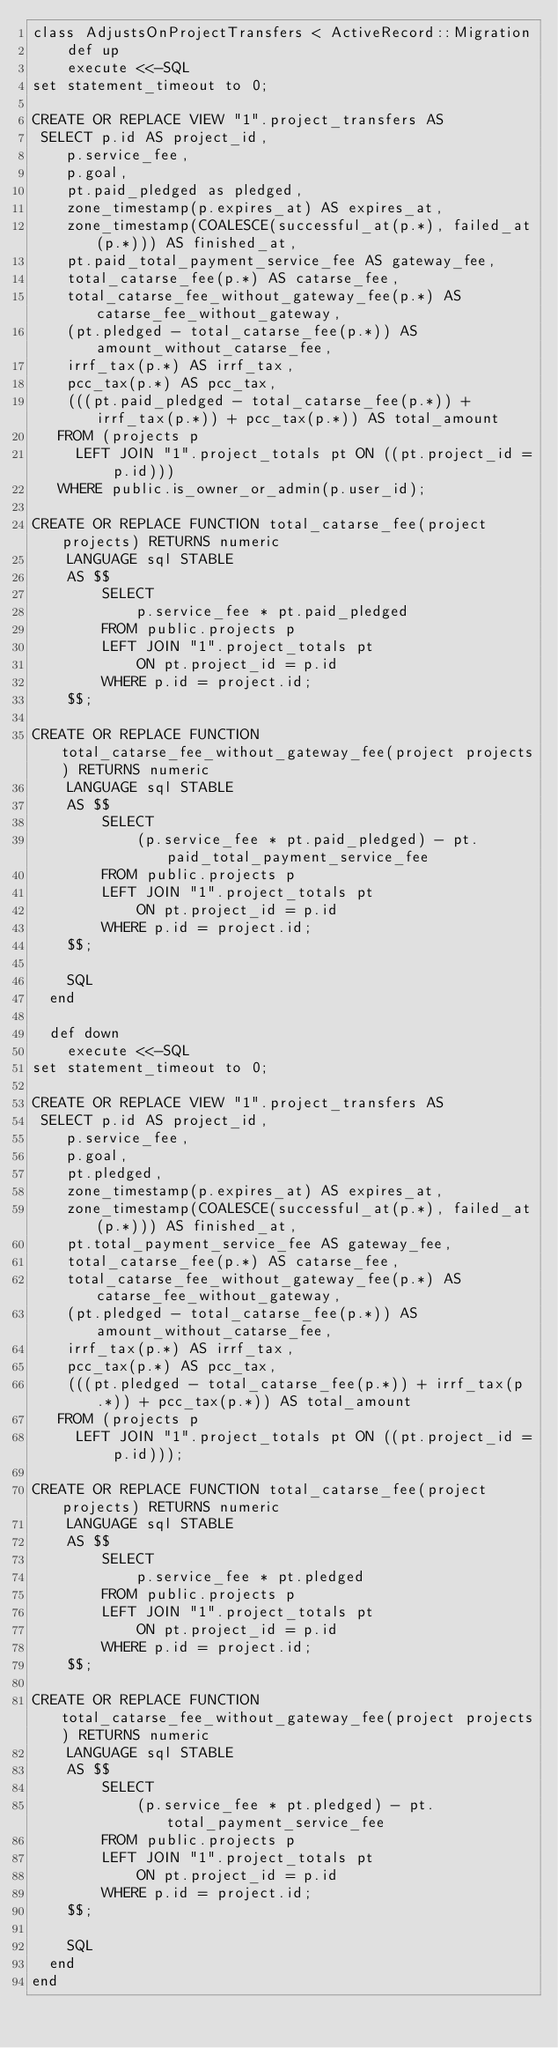<code> <loc_0><loc_0><loc_500><loc_500><_Ruby_>class AdjustsOnProjectTransfers < ActiveRecord::Migration
    def up
    execute <<-SQL
set statement_timeout to 0;

CREATE OR REPLACE VIEW "1".project_transfers AS
 SELECT p.id AS project_id,
    p.service_fee,
    p.goal,
    pt.paid_pledged as pledged,
    zone_timestamp(p.expires_at) AS expires_at,
    zone_timestamp(COALESCE(successful_at(p.*), failed_at(p.*))) AS finished_at,
    pt.paid_total_payment_service_fee AS gateway_fee,
    total_catarse_fee(p.*) AS catarse_fee,
    total_catarse_fee_without_gateway_fee(p.*) AS catarse_fee_without_gateway,
    (pt.pledged - total_catarse_fee(p.*)) AS amount_without_catarse_fee,
    irrf_tax(p.*) AS irrf_tax,
    pcc_tax(p.*) AS pcc_tax,
    (((pt.paid_pledged - total_catarse_fee(p.*)) + irrf_tax(p.*)) + pcc_tax(p.*)) AS total_amount
   FROM (projects p
     LEFT JOIN "1".project_totals pt ON ((pt.project_id = p.id)))
   WHERE public.is_owner_or_admin(p.user_id);

CREATE OR REPLACE FUNCTION total_catarse_fee(project projects) RETURNS numeric
    LANGUAGE sql STABLE
    AS $$
        SELECT
            p.service_fee * pt.paid_pledged
        FROM public.projects p
        LEFT JOIN "1".project_totals pt
            ON pt.project_id = p.id
        WHERE p.id = project.id;
    $$;

CREATE OR REPLACE FUNCTION total_catarse_fee_without_gateway_fee(project projects) RETURNS numeric
    LANGUAGE sql STABLE
    AS $$
        SELECT
            (p.service_fee * pt.paid_pledged) - pt.paid_total_payment_service_fee
        FROM public.projects p
        LEFT JOIN "1".project_totals pt
            ON pt.project_id = p.id
        WHERE p.id = project.id;
    $$;

    SQL
  end

  def down
    execute <<-SQL
set statement_timeout to 0;

CREATE OR REPLACE VIEW "1".project_transfers AS
 SELECT p.id AS project_id,
    p.service_fee,
    p.goal,
    pt.pledged,
    zone_timestamp(p.expires_at) AS expires_at,
    zone_timestamp(COALESCE(successful_at(p.*), failed_at(p.*))) AS finished_at,
    pt.total_payment_service_fee AS gateway_fee,
    total_catarse_fee(p.*) AS catarse_fee,
    total_catarse_fee_without_gateway_fee(p.*) AS catarse_fee_without_gateway,
    (pt.pledged - total_catarse_fee(p.*)) AS amount_without_catarse_fee,
    irrf_tax(p.*) AS irrf_tax,
    pcc_tax(p.*) AS pcc_tax,
    (((pt.pledged - total_catarse_fee(p.*)) + irrf_tax(p.*)) + pcc_tax(p.*)) AS total_amount
   FROM (projects p
     LEFT JOIN "1".project_totals pt ON ((pt.project_id = p.id)));

CREATE OR REPLACE FUNCTION total_catarse_fee(project projects) RETURNS numeric
    LANGUAGE sql STABLE
    AS $$
        SELECT
            p.service_fee * pt.pledged
        FROM public.projects p
        LEFT JOIN "1".project_totals pt
            ON pt.project_id = p.id
        WHERE p.id = project.id;
    $$;

CREATE OR REPLACE FUNCTION total_catarse_fee_without_gateway_fee(project projects) RETURNS numeric
    LANGUAGE sql STABLE
    AS $$
        SELECT
            (p.service_fee * pt.pledged) - pt.total_payment_service_fee
        FROM public.projects p
        LEFT JOIN "1".project_totals pt
            ON pt.project_id = p.id
        WHERE p.id = project.id;
    $$;

    SQL
  end
end
</code> 